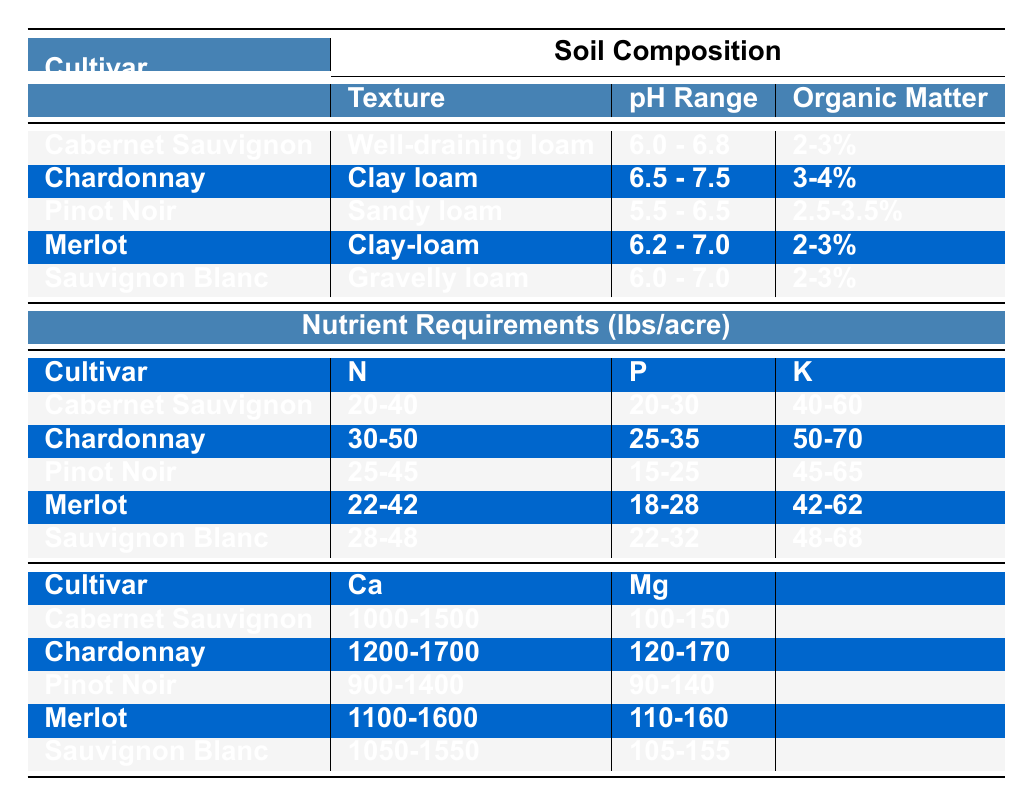What is the pH range for Chardonnay? The table lists the pH range for each cultivar under the Soil Composition section. For Chardonnay, the pH range is specified as 6.5 - 7.5.
Answer: 6.5 - 7.5 Which cultivar has the highest required potassium (K) level? By comparing the potassium (K) values in the Nutrient Requirements section, Chardonnay has the highest required range of 50-70 lbs/acre.
Answer: Chardonnay What is the average nitrogen (N) requirement for all cultivars? To calculate the average nitrogen requirement, first, find the midpoints of each nitrogen range: Cabernet Sauvignon (30), Chardonnay (40), Pinot Noir (35), Merlot (32), Sauvignon Blanc (38). The sum is 30 + 40 + 35 + 32 + 38 = 175. There are 5 cultivars, so the average is 175/5 = 35.
Answer: 35 Does Pinot Noir have a higher calcium (Ca) requirement than Sauvignon Blanc? The calcium requirements for each cultivar are compared: Pinot Noir requires 900-1400 lbs/acre, and Sauvignon Blanc requires 1050-1550 lbs/acre. Since the requirement ranges overlap and Sauvignon Blanc has a higher minimum, the answer is yes.
Answer: Yes What is the total range of phosphorus (P) that Cabernet Sauvignon and Merlot require combined? The phosphorus ranges for both cultivars are: Cabernet Sauvignon (20-30 lbs/acre) and Merlot (18-28 lbs/acre). The combined range minimum is 20+18=38 and maximum is 30+28=58, giving a total range of 38-58 lbs/acre.
Answer: 38-58 lbs/acre Which cultivar requires the least amount of organic matter? The organic matter requirements are compared: Cabernet Sauvignon (2-3%), Chardonnay (3-4%), Pinot Noir (2.5-3.5%), Merlot (2-3%), and Sauvignon Blanc (2-3%). The least requirement is from Cabernet Sauvignon and Merlot as both have the minimum of 2%.
Answer: Cabernet Sauvignon and Merlot How much more magnesium (Mg) does Chardonnay require compared to Pinot Noir? By looking at the magnesium requirements, Chardonnay requires 120-170 lbs/acre while Pinot Noir requires 90-140 lbs/acre. The maximum difference is 170 - 90 = 80 lbs/acre.
Answer: 80 lbs/acre Is there any cultivar that requires all nutrient levels below 30 lbs/acre? Examining all nutrient requirements shows no cultivar has all required levels below 30 lbs/acre. For instance, both Sauvignon Blanc and Pinot Noir have phosphorus requirements above this threshold.
Answer: No 